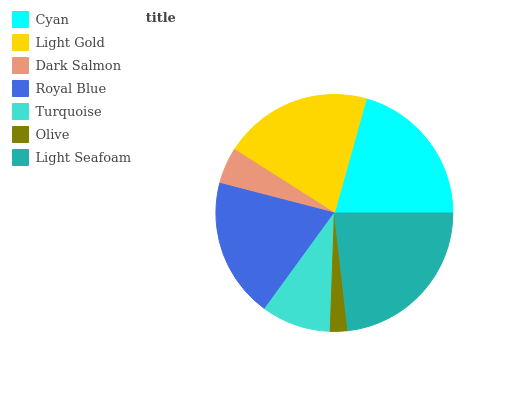Is Olive the minimum?
Answer yes or no. Yes. Is Light Seafoam the maximum?
Answer yes or no. Yes. Is Light Gold the minimum?
Answer yes or no. No. Is Light Gold the maximum?
Answer yes or no. No. Is Cyan greater than Light Gold?
Answer yes or no. Yes. Is Light Gold less than Cyan?
Answer yes or no. Yes. Is Light Gold greater than Cyan?
Answer yes or no. No. Is Cyan less than Light Gold?
Answer yes or no. No. Is Royal Blue the high median?
Answer yes or no. Yes. Is Royal Blue the low median?
Answer yes or no. Yes. Is Dark Salmon the high median?
Answer yes or no. No. Is Dark Salmon the low median?
Answer yes or no. No. 